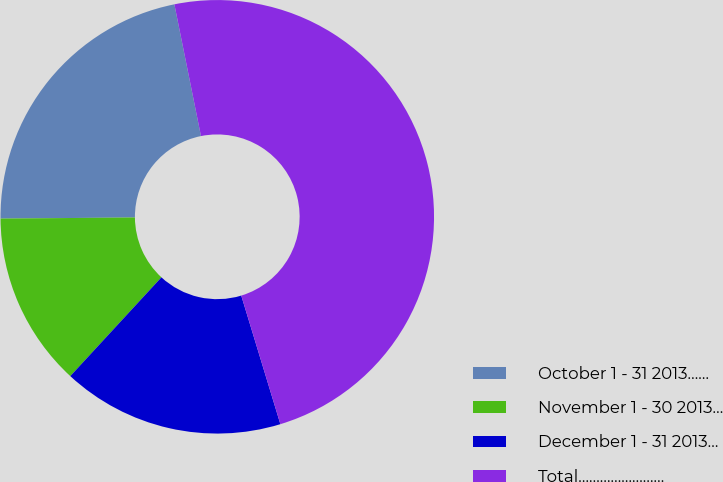Convert chart. <chart><loc_0><loc_0><loc_500><loc_500><pie_chart><fcel>October 1 - 31 2013……<fcel>November 1 - 30 2013…<fcel>December 1 - 31 2013…<fcel>Total……………………<nl><fcel>21.96%<fcel>13.01%<fcel>16.56%<fcel>48.47%<nl></chart> 